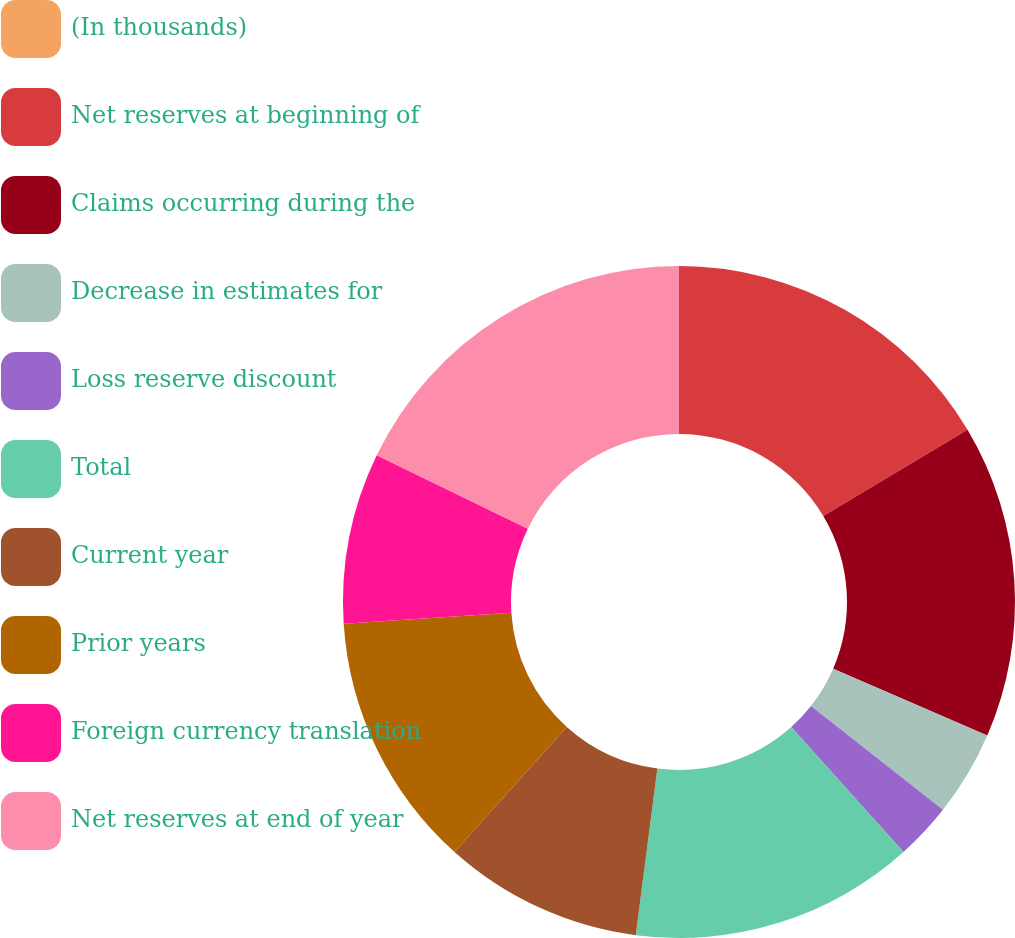<chart> <loc_0><loc_0><loc_500><loc_500><pie_chart><fcel>(In thousands)<fcel>Net reserves at beginning of<fcel>Claims occurring during the<fcel>Decrease in estimates for<fcel>Loss reserve discount<fcel>Total<fcel>Current year<fcel>Prior years<fcel>Foreign currency translation<fcel>Net reserves at end of year<nl><fcel>0.0%<fcel>16.44%<fcel>15.07%<fcel>4.11%<fcel>2.74%<fcel>13.7%<fcel>9.59%<fcel>12.33%<fcel>8.22%<fcel>17.81%<nl></chart> 